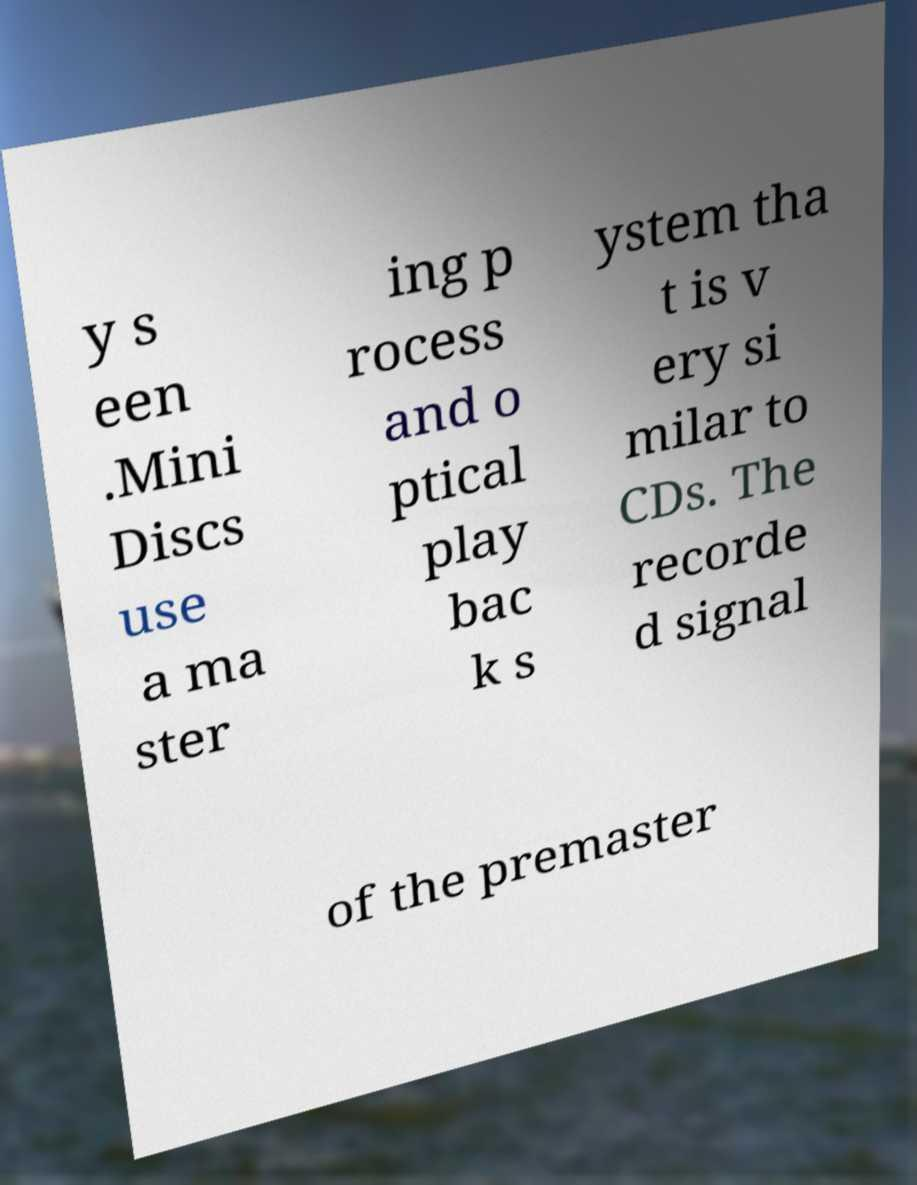Can you read and provide the text displayed in the image?This photo seems to have some interesting text. Can you extract and type it out for me? y s een .Mini Discs use a ma ster ing p rocess and o ptical play bac k s ystem tha t is v ery si milar to CDs. The recorde d signal of the premaster 